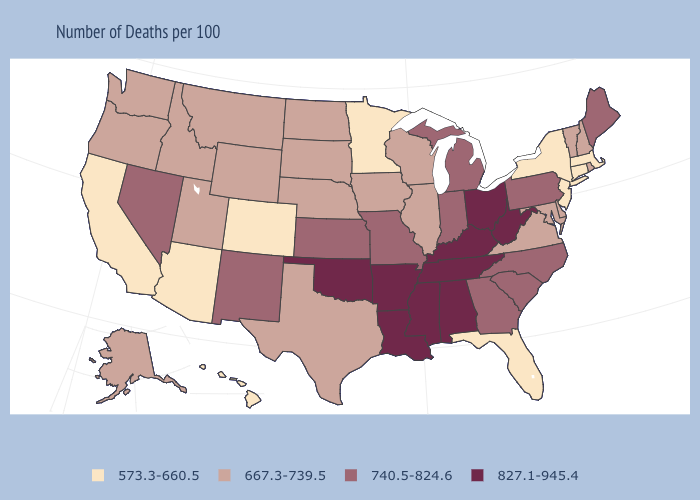Which states have the highest value in the USA?
Concise answer only. Alabama, Arkansas, Kentucky, Louisiana, Mississippi, Ohio, Oklahoma, Tennessee, West Virginia. What is the value of California?
Answer briefly. 573.3-660.5. What is the highest value in the USA?
Be succinct. 827.1-945.4. Does Maine have the highest value in the Northeast?
Keep it brief. Yes. Among the states that border Georgia , does Florida have the lowest value?
Keep it brief. Yes. What is the value of Alabama?
Be succinct. 827.1-945.4. Does Maine have a higher value than Illinois?
Write a very short answer. Yes. Among the states that border Iowa , does South Dakota have the highest value?
Keep it brief. No. Among the states that border New York , does Connecticut have the highest value?
Concise answer only. No. Is the legend a continuous bar?
Keep it brief. No. What is the highest value in states that border Georgia?
Answer briefly. 827.1-945.4. Name the states that have a value in the range 667.3-739.5?
Short answer required. Alaska, Delaware, Idaho, Illinois, Iowa, Maryland, Montana, Nebraska, New Hampshire, North Dakota, Oregon, Rhode Island, South Dakota, Texas, Utah, Vermont, Virginia, Washington, Wisconsin, Wyoming. Does Illinois have a lower value than New Mexico?
Give a very brief answer. Yes. What is the value of Maryland?
Be succinct. 667.3-739.5. 